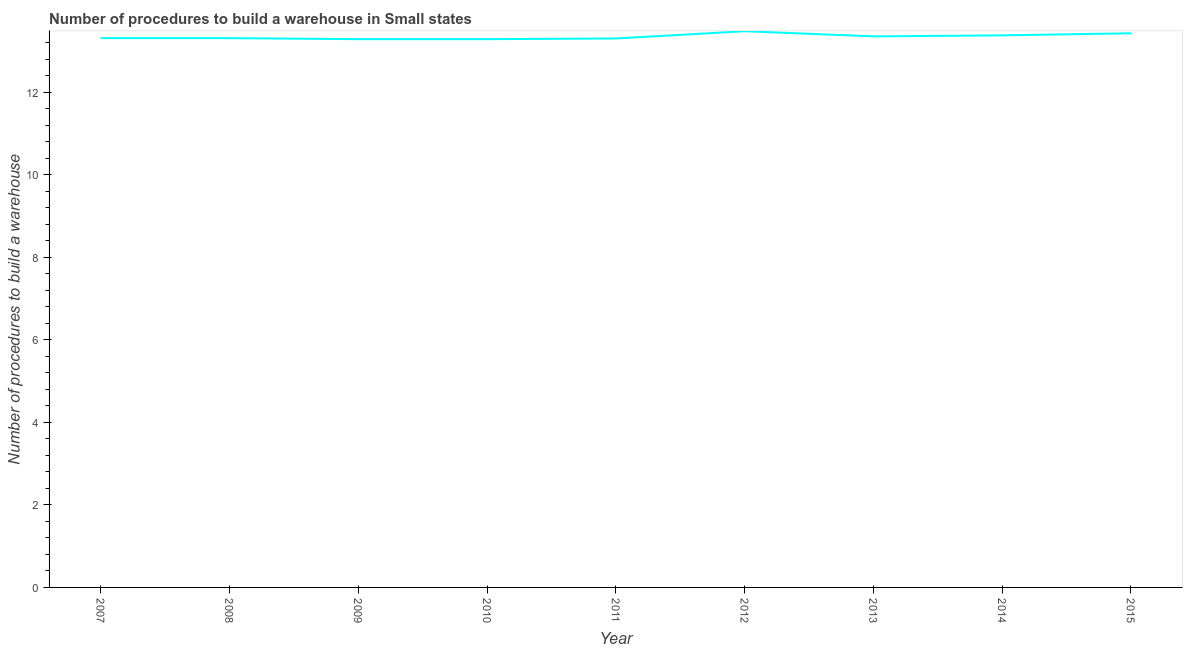What is the number of procedures to build a warehouse in 2008?
Your answer should be compact. 13.31. Across all years, what is the maximum number of procedures to build a warehouse?
Make the answer very short. 13.47. Across all years, what is the minimum number of procedures to build a warehouse?
Your response must be concise. 13.28. In which year was the number of procedures to build a warehouse maximum?
Your answer should be compact. 2012. What is the sum of the number of procedures to build a warehouse?
Provide a succinct answer. 120.1. What is the difference between the number of procedures to build a warehouse in 2009 and 2011?
Provide a short and direct response. -0.02. What is the average number of procedures to build a warehouse per year?
Give a very brief answer. 13.34. What is the median number of procedures to build a warehouse?
Give a very brief answer. 13.31. In how many years, is the number of procedures to build a warehouse greater than 8 ?
Offer a terse response. 9. What is the ratio of the number of procedures to build a warehouse in 2008 to that in 2015?
Ensure brevity in your answer.  0.99. What is the difference between the highest and the second highest number of procedures to build a warehouse?
Keep it short and to the point. 0.05. What is the difference between the highest and the lowest number of procedures to build a warehouse?
Ensure brevity in your answer.  0.19. Does the number of procedures to build a warehouse monotonically increase over the years?
Your answer should be very brief. No. How many lines are there?
Offer a very short reply. 1. How many years are there in the graph?
Make the answer very short. 9. What is the difference between two consecutive major ticks on the Y-axis?
Provide a short and direct response. 2. What is the title of the graph?
Keep it short and to the point. Number of procedures to build a warehouse in Small states. What is the label or title of the X-axis?
Offer a very short reply. Year. What is the label or title of the Y-axis?
Your answer should be very brief. Number of procedures to build a warehouse. What is the Number of procedures to build a warehouse of 2007?
Provide a succinct answer. 13.31. What is the Number of procedures to build a warehouse in 2008?
Your answer should be compact. 13.31. What is the Number of procedures to build a warehouse of 2009?
Provide a short and direct response. 13.28. What is the Number of procedures to build a warehouse of 2010?
Ensure brevity in your answer.  13.28. What is the Number of procedures to build a warehouse in 2012?
Make the answer very short. 13.47. What is the Number of procedures to build a warehouse in 2013?
Offer a terse response. 13.35. What is the Number of procedures to build a warehouse in 2014?
Your answer should be compact. 13.38. What is the Number of procedures to build a warehouse of 2015?
Your response must be concise. 13.43. What is the difference between the Number of procedures to build a warehouse in 2007 and 2009?
Your response must be concise. 0.03. What is the difference between the Number of procedures to build a warehouse in 2007 and 2010?
Offer a terse response. 0.03. What is the difference between the Number of procedures to build a warehouse in 2007 and 2011?
Ensure brevity in your answer.  0.01. What is the difference between the Number of procedures to build a warehouse in 2007 and 2012?
Your answer should be compact. -0.17. What is the difference between the Number of procedures to build a warehouse in 2007 and 2013?
Keep it short and to the point. -0.04. What is the difference between the Number of procedures to build a warehouse in 2007 and 2014?
Offer a terse response. -0.07. What is the difference between the Number of procedures to build a warehouse in 2007 and 2015?
Your answer should be very brief. -0.12. What is the difference between the Number of procedures to build a warehouse in 2008 and 2009?
Offer a terse response. 0.03. What is the difference between the Number of procedures to build a warehouse in 2008 and 2010?
Give a very brief answer. 0.03. What is the difference between the Number of procedures to build a warehouse in 2008 and 2011?
Your response must be concise. 0.01. What is the difference between the Number of procedures to build a warehouse in 2008 and 2012?
Give a very brief answer. -0.17. What is the difference between the Number of procedures to build a warehouse in 2008 and 2013?
Make the answer very short. -0.04. What is the difference between the Number of procedures to build a warehouse in 2008 and 2014?
Provide a succinct answer. -0.07. What is the difference between the Number of procedures to build a warehouse in 2008 and 2015?
Provide a short and direct response. -0.12. What is the difference between the Number of procedures to build a warehouse in 2009 and 2010?
Ensure brevity in your answer.  0. What is the difference between the Number of procedures to build a warehouse in 2009 and 2011?
Provide a succinct answer. -0.02. What is the difference between the Number of procedures to build a warehouse in 2009 and 2012?
Offer a terse response. -0.19. What is the difference between the Number of procedures to build a warehouse in 2009 and 2013?
Keep it short and to the point. -0.07. What is the difference between the Number of procedures to build a warehouse in 2009 and 2014?
Your answer should be compact. -0.09. What is the difference between the Number of procedures to build a warehouse in 2009 and 2015?
Keep it short and to the point. -0.14. What is the difference between the Number of procedures to build a warehouse in 2010 and 2011?
Your answer should be very brief. -0.02. What is the difference between the Number of procedures to build a warehouse in 2010 and 2012?
Ensure brevity in your answer.  -0.19. What is the difference between the Number of procedures to build a warehouse in 2010 and 2013?
Your response must be concise. -0.07. What is the difference between the Number of procedures to build a warehouse in 2010 and 2014?
Offer a terse response. -0.09. What is the difference between the Number of procedures to build a warehouse in 2010 and 2015?
Give a very brief answer. -0.14. What is the difference between the Number of procedures to build a warehouse in 2011 and 2012?
Your answer should be compact. -0.17. What is the difference between the Number of procedures to build a warehouse in 2011 and 2013?
Ensure brevity in your answer.  -0.05. What is the difference between the Number of procedures to build a warehouse in 2011 and 2014?
Your answer should be very brief. -0.07. What is the difference between the Number of procedures to build a warehouse in 2011 and 2015?
Your answer should be compact. -0.12. What is the difference between the Number of procedures to build a warehouse in 2012 and 2013?
Your answer should be compact. 0.12. What is the difference between the Number of procedures to build a warehouse in 2012 and 2015?
Keep it short and to the point. 0.05. What is the difference between the Number of procedures to build a warehouse in 2013 and 2014?
Give a very brief answer. -0.03. What is the difference between the Number of procedures to build a warehouse in 2013 and 2015?
Offer a terse response. -0.07. What is the difference between the Number of procedures to build a warehouse in 2014 and 2015?
Give a very brief answer. -0.05. What is the ratio of the Number of procedures to build a warehouse in 2007 to that in 2009?
Offer a terse response. 1. What is the ratio of the Number of procedures to build a warehouse in 2007 to that in 2012?
Your response must be concise. 0.99. What is the ratio of the Number of procedures to build a warehouse in 2007 to that in 2014?
Give a very brief answer. 0.99. What is the ratio of the Number of procedures to build a warehouse in 2007 to that in 2015?
Your answer should be very brief. 0.99. What is the ratio of the Number of procedures to build a warehouse in 2008 to that in 2010?
Make the answer very short. 1. What is the ratio of the Number of procedures to build a warehouse in 2009 to that in 2013?
Your answer should be very brief. 0.99. What is the ratio of the Number of procedures to build a warehouse in 2009 to that in 2015?
Give a very brief answer. 0.99. What is the ratio of the Number of procedures to build a warehouse in 2010 to that in 2011?
Make the answer very short. 1. What is the ratio of the Number of procedures to build a warehouse in 2010 to that in 2014?
Make the answer very short. 0.99. What is the ratio of the Number of procedures to build a warehouse in 2011 to that in 2012?
Make the answer very short. 0.99. What is the ratio of the Number of procedures to build a warehouse in 2011 to that in 2014?
Your answer should be compact. 0.99. What is the ratio of the Number of procedures to build a warehouse in 2013 to that in 2015?
Offer a very short reply. 0.99. 